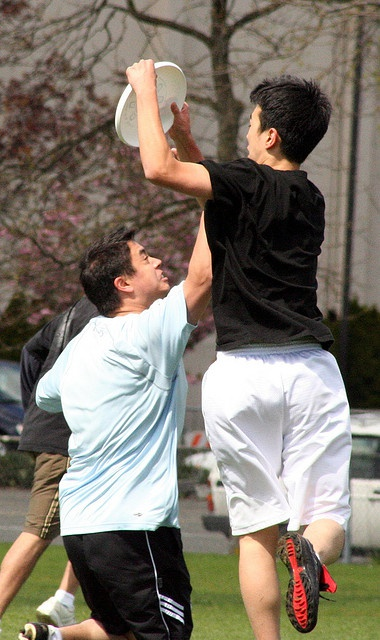Describe the objects in this image and their specific colors. I can see people in gray, black, white, darkgray, and tan tones, people in gray, white, black, darkgray, and lightblue tones, people in gray, black, and olive tones, car in gray, darkgray, lightgray, and black tones, and frisbee in gray, darkgray, white, and tan tones in this image. 